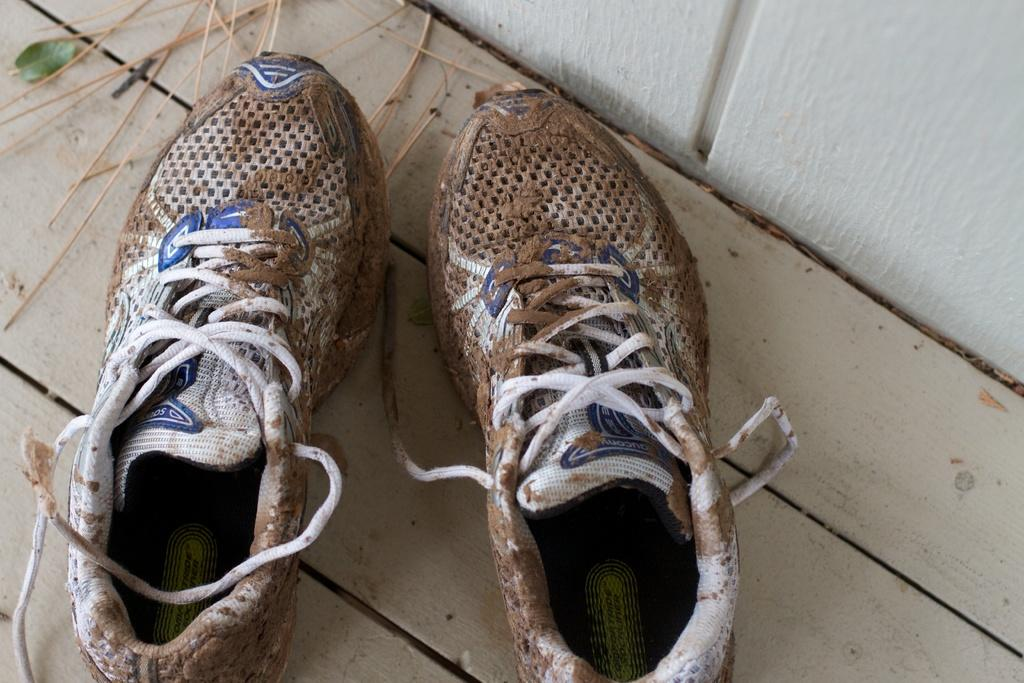What objects are in the foreground of the image? There are muddy shoes in the foreground of the image. What surface are the shoes placed on? The shoes are on a wooden surface. What can be seen in the background of the image? There is a white wall in the background of the image. What is visible at the top of the image? There are sticks visible at the top of the image. What type of engine can be seen in the image? There is no engine present in the image. What is the purpose of the plate in the image? There is no plate present in the image. 